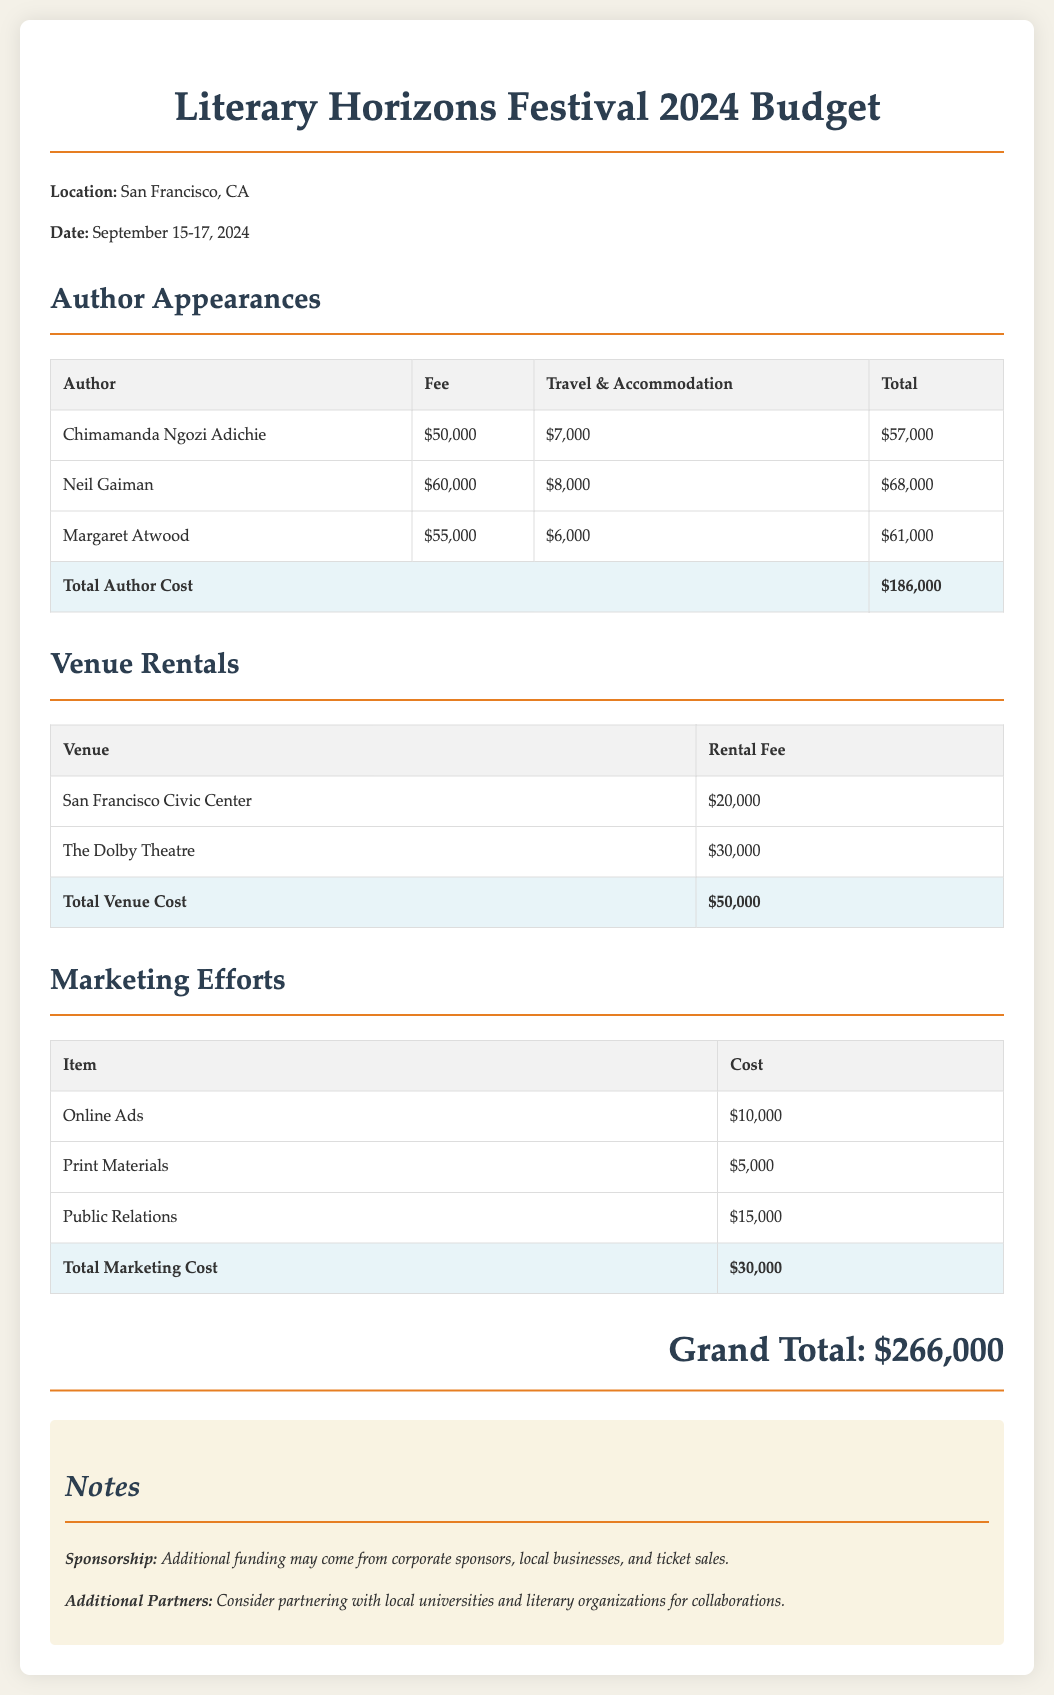What is the total author cost? The total author cost is the sum of all fees and related expenses for authors, totaling $186,000.
Answer: $186,000 What is the rental fee for The Dolby Theatre? The rental fee for The Dolby Theatre is explicitly stated in the document as $30,000.
Answer: $30,000 Who is the author with a total cost of $68,000? The author with a total cost of $68,000 is listed in the document as Neil Gaiman.
Answer: Neil Gaiman What is the total marketing cost? The total marketing cost is derived from the sum of all marketing efforts, totaling $30,000.
Answer: $30,000 What is the grand total for the budget? The grand total is the overall sum of all costs in the budget, which is stated as $266,000.
Answer: $266,000 How many authors are listed in the document? The document lists a total of three authors who have fees and travel costs detailed.
Answer: Three What is the date of the Literary Horizons Festival? The date of the festival is mentioned in the document as September 15-17, 2024.
Answer: September 15-17, 2024 What is the lowest author fee listed? The lowest author fee among those mentioned in the document is $50,000 for Chimamanda Ngozi Adichie.
Answer: $50,000 What type of document is this? This document is specifically a budget outlining costs associated with a literary festival.
Answer: Budget 